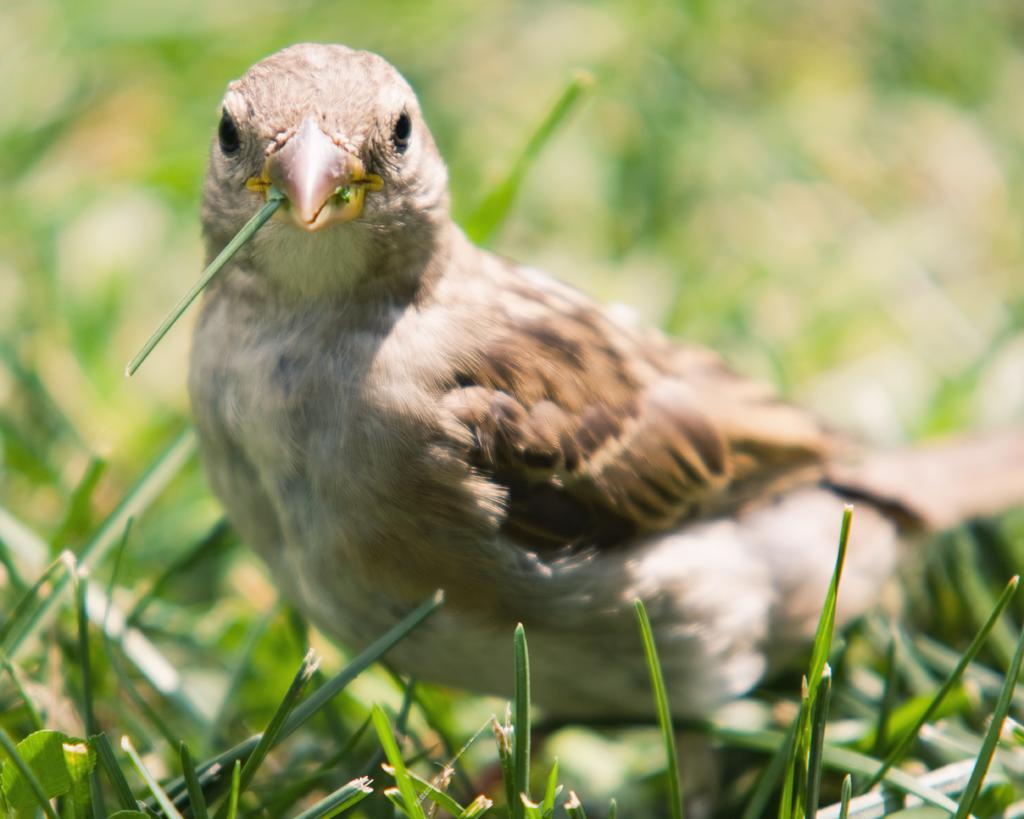Can you describe this image briefly? In this image we can see a bird and also the grass. The background is blurred. 